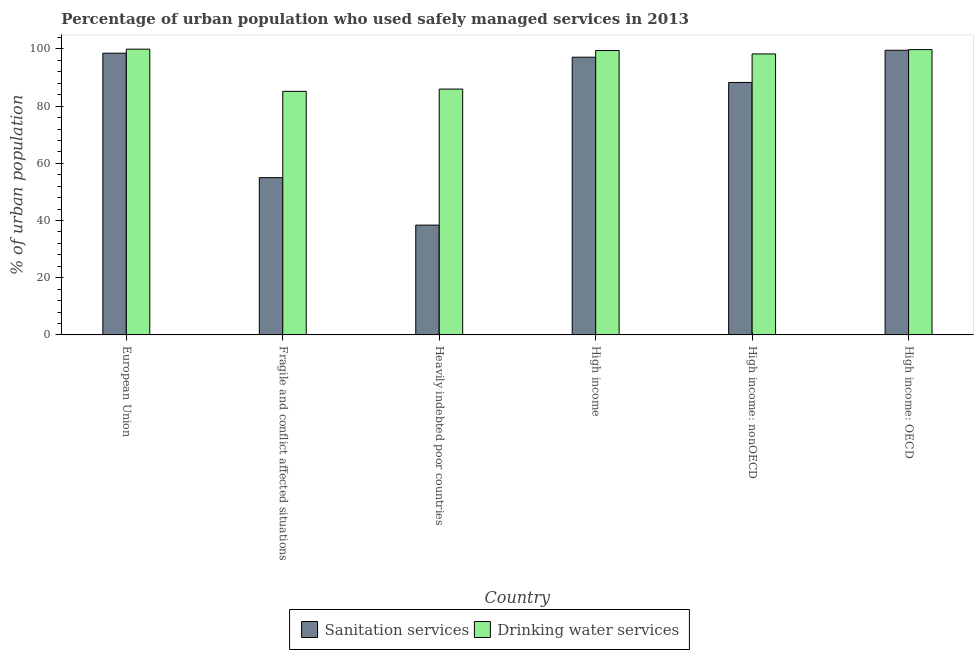How many groups of bars are there?
Your response must be concise. 6. Are the number of bars per tick equal to the number of legend labels?
Your response must be concise. Yes. How many bars are there on the 1st tick from the left?
Give a very brief answer. 2. What is the label of the 5th group of bars from the left?
Your answer should be very brief. High income: nonOECD. In how many cases, is the number of bars for a given country not equal to the number of legend labels?
Provide a short and direct response. 0. What is the percentage of urban population who used sanitation services in High income: nonOECD?
Your answer should be very brief. 88.28. Across all countries, what is the maximum percentage of urban population who used sanitation services?
Your answer should be compact. 99.55. Across all countries, what is the minimum percentage of urban population who used sanitation services?
Your answer should be very brief. 38.4. In which country was the percentage of urban population who used sanitation services maximum?
Keep it short and to the point. High income: OECD. In which country was the percentage of urban population who used drinking water services minimum?
Offer a terse response. Fragile and conflict affected situations. What is the total percentage of urban population who used drinking water services in the graph?
Give a very brief answer. 568.56. What is the difference between the percentage of urban population who used drinking water services in European Union and that in High income?
Your answer should be very brief. 0.48. What is the difference between the percentage of urban population who used sanitation services in European Union and the percentage of urban population who used drinking water services in Heavily indebted poor countries?
Ensure brevity in your answer.  12.55. What is the average percentage of urban population who used drinking water services per country?
Offer a terse response. 94.76. What is the difference between the percentage of urban population who used drinking water services and percentage of urban population who used sanitation services in Fragile and conflict affected situations?
Provide a short and direct response. 30.18. In how many countries, is the percentage of urban population who used sanitation services greater than 28 %?
Give a very brief answer. 6. What is the ratio of the percentage of urban population who used sanitation services in European Union to that in High income: OECD?
Keep it short and to the point. 0.99. Is the percentage of urban population who used drinking water services in European Union less than that in High income: OECD?
Offer a terse response. No. What is the difference between the highest and the second highest percentage of urban population who used sanitation services?
Your response must be concise. 1.03. What is the difference between the highest and the lowest percentage of urban population who used drinking water services?
Offer a terse response. 14.76. In how many countries, is the percentage of urban population who used sanitation services greater than the average percentage of urban population who used sanitation services taken over all countries?
Provide a succinct answer. 4. What does the 2nd bar from the left in High income: nonOECD represents?
Make the answer very short. Drinking water services. What does the 1st bar from the right in Heavily indebted poor countries represents?
Make the answer very short. Drinking water services. Are all the bars in the graph horizontal?
Your response must be concise. No. How many countries are there in the graph?
Ensure brevity in your answer.  6. What is the difference between two consecutive major ticks on the Y-axis?
Give a very brief answer. 20. Does the graph contain any zero values?
Offer a terse response. No. How many legend labels are there?
Your answer should be compact. 2. What is the title of the graph?
Your response must be concise. Percentage of urban population who used safely managed services in 2013. Does "Urban agglomerations" appear as one of the legend labels in the graph?
Provide a short and direct response. No. What is the label or title of the X-axis?
Your answer should be very brief. Country. What is the label or title of the Y-axis?
Ensure brevity in your answer.  % of urban population. What is the % of urban population of Sanitation services in European Union?
Keep it short and to the point. 98.52. What is the % of urban population in Drinking water services in European Union?
Your answer should be very brief. 99.93. What is the % of urban population in Sanitation services in Fragile and conflict affected situations?
Keep it short and to the point. 55. What is the % of urban population in Drinking water services in Fragile and conflict affected situations?
Provide a short and direct response. 85.17. What is the % of urban population in Sanitation services in Heavily indebted poor countries?
Ensure brevity in your answer.  38.4. What is the % of urban population of Drinking water services in Heavily indebted poor countries?
Your response must be concise. 85.97. What is the % of urban population of Sanitation services in High income?
Provide a succinct answer. 97.11. What is the % of urban population of Drinking water services in High income?
Ensure brevity in your answer.  99.45. What is the % of urban population in Sanitation services in High income: nonOECD?
Give a very brief answer. 88.28. What is the % of urban population of Drinking water services in High income: nonOECD?
Your answer should be very brief. 98.26. What is the % of urban population of Sanitation services in High income: OECD?
Ensure brevity in your answer.  99.55. What is the % of urban population of Drinking water services in High income: OECD?
Make the answer very short. 99.77. Across all countries, what is the maximum % of urban population in Sanitation services?
Your answer should be very brief. 99.55. Across all countries, what is the maximum % of urban population of Drinking water services?
Your response must be concise. 99.93. Across all countries, what is the minimum % of urban population of Sanitation services?
Offer a terse response. 38.4. Across all countries, what is the minimum % of urban population of Drinking water services?
Provide a short and direct response. 85.17. What is the total % of urban population in Sanitation services in the graph?
Offer a terse response. 476.85. What is the total % of urban population in Drinking water services in the graph?
Offer a very short reply. 568.56. What is the difference between the % of urban population of Sanitation services in European Union and that in Fragile and conflict affected situations?
Your answer should be very brief. 43.52. What is the difference between the % of urban population in Drinking water services in European Union and that in Fragile and conflict affected situations?
Your answer should be very brief. 14.76. What is the difference between the % of urban population in Sanitation services in European Union and that in Heavily indebted poor countries?
Your response must be concise. 60.12. What is the difference between the % of urban population of Drinking water services in European Union and that in Heavily indebted poor countries?
Ensure brevity in your answer.  13.96. What is the difference between the % of urban population of Sanitation services in European Union and that in High income?
Give a very brief answer. 1.4. What is the difference between the % of urban population of Drinking water services in European Union and that in High income?
Your response must be concise. 0.48. What is the difference between the % of urban population in Sanitation services in European Union and that in High income: nonOECD?
Make the answer very short. 10.23. What is the difference between the % of urban population of Drinking water services in European Union and that in High income: nonOECD?
Give a very brief answer. 1.66. What is the difference between the % of urban population in Sanitation services in European Union and that in High income: OECD?
Your answer should be very brief. -1.03. What is the difference between the % of urban population in Drinking water services in European Union and that in High income: OECD?
Keep it short and to the point. 0.15. What is the difference between the % of urban population in Sanitation services in Fragile and conflict affected situations and that in Heavily indebted poor countries?
Your answer should be very brief. 16.6. What is the difference between the % of urban population in Drinking water services in Fragile and conflict affected situations and that in Heavily indebted poor countries?
Give a very brief answer. -0.8. What is the difference between the % of urban population in Sanitation services in Fragile and conflict affected situations and that in High income?
Provide a succinct answer. -42.12. What is the difference between the % of urban population in Drinking water services in Fragile and conflict affected situations and that in High income?
Give a very brief answer. -14.28. What is the difference between the % of urban population of Sanitation services in Fragile and conflict affected situations and that in High income: nonOECD?
Provide a succinct answer. -33.29. What is the difference between the % of urban population of Drinking water services in Fragile and conflict affected situations and that in High income: nonOECD?
Your answer should be very brief. -13.09. What is the difference between the % of urban population in Sanitation services in Fragile and conflict affected situations and that in High income: OECD?
Offer a terse response. -44.55. What is the difference between the % of urban population of Drinking water services in Fragile and conflict affected situations and that in High income: OECD?
Provide a succinct answer. -14.6. What is the difference between the % of urban population of Sanitation services in Heavily indebted poor countries and that in High income?
Keep it short and to the point. -58.72. What is the difference between the % of urban population of Drinking water services in Heavily indebted poor countries and that in High income?
Offer a very short reply. -13.48. What is the difference between the % of urban population in Sanitation services in Heavily indebted poor countries and that in High income: nonOECD?
Provide a succinct answer. -49.89. What is the difference between the % of urban population in Drinking water services in Heavily indebted poor countries and that in High income: nonOECD?
Keep it short and to the point. -12.29. What is the difference between the % of urban population of Sanitation services in Heavily indebted poor countries and that in High income: OECD?
Keep it short and to the point. -61.15. What is the difference between the % of urban population in Drinking water services in Heavily indebted poor countries and that in High income: OECD?
Ensure brevity in your answer.  -13.8. What is the difference between the % of urban population in Sanitation services in High income and that in High income: nonOECD?
Provide a short and direct response. 8.83. What is the difference between the % of urban population in Drinking water services in High income and that in High income: nonOECD?
Your answer should be compact. 1.19. What is the difference between the % of urban population of Sanitation services in High income and that in High income: OECD?
Your answer should be very brief. -2.43. What is the difference between the % of urban population of Drinking water services in High income and that in High income: OECD?
Your response must be concise. -0.32. What is the difference between the % of urban population in Sanitation services in High income: nonOECD and that in High income: OECD?
Your answer should be compact. -11.26. What is the difference between the % of urban population of Drinking water services in High income: nonOECD and that in High income: OECD?
Your answer should be very brief. -1.51. What is the difference between the % of urban population in Sanitation services in European Union and the % of urban population in Drinking water services in Fragile and conflict affected situations?
Your answer should be very brief. 13.35. What is the difference between the % of urban population of Sanitation services in European Union and the % of urban population of Drinking water services in Heavily indebted poor countries?
Offer a terse response. 12.55. What is the difference between the % of urban population in Sanitation services in European Union and the % of urban population in Drinking water services in High income?
Offer a very short reply. -0.94. What is the difference between the % of urban population in Sanitation services in European Union and the % of urban population in Drinking water services in High income: nonOECD?
Your response must be concise. 0.25. What is the difference between the % of urban population in Sanitation services in European Union and the % of urban population in Drinking water services in High income: OECD?
Your response must be concise. -1.26. What is the difference between the % of urban population in Sanitation services in Fragile and conflict affected situations and the % of urban population in Drinking water services in Heavily indebted poor countries?
Make the answer very short. -30.98. What is the difference between the % of urban population in Sanitation services in Fragile and conflict affected situations and the % of urban population in Drinking water services in High income?
Ensure brevity in your answer.  -44.46. What is the difference between the % of urban population of Sanitation services in Fragile and conflict affected situations and the % of urban population of Drinking water services in High income: nonOECD?
Offer a terse response. -43.27. What is the difference between the % of urban population of Sanitation services in Fragile and conflict affected situations and the % of urban population of Drinking water services in High income: OECD?
Give a very brief answer. -44.78. What is the difference between the % of urban population of Sanitation services in Heavily indebted poor countries and the % of urban population of Drinking water services in High income?
Your response must be concise. -61.06. What is the difference between the % of urban population in Sanitation services in Heavily indebted poor countries and the % of urban population in Drinking water services in High income: nonOECD?
Give a very brief answer. -59.87. What is the difference between the % of urban population in Sanitation services in Heavily indebted poor countries and the % of urban population in Drinking water services in High income: OECD?
Provide a short and direct response. -61.38. What is the difference between the % of urban population of Sanitation services in High income and the % of urban population of Drinking water services in High income: nonOECD?
Your answer should be compact. -1.15. What is the difference between the % of urban population in Sanitation services in High income and the % of urban population in Drinking water services in High income: OECD?
Your answer should be very brief. -2.66. What is the difference between the % of urban population in Sanitation services in High income: nonOECD and the % of urban population in Drinking water services in High income: OECD?
Your response must be concise. -11.49. What is the average % of urban population in Sanitation services per country?
Offer a terse response. 79.48. What is the average % of urban population of Drinking water services per country?
Ensure brevity in your answer.  94.76. What is the difference between the % of urban population of Sanitation services and % of urban population of Drinking water services in European Union?
Keep it short and to the point. -1.41. What is the difference between the % of urban population in Sanitation services and % of urban population in Drinking water services in Fragile and conflict affected situations?
Offer a terse response. -30.18. What is the difference between the % of urban population in Sanitation services and % of urban population in Drinking water services in Heavily indebted poor countries?
Offer a very short reply. -47.57. What is the difference between the % of urban population in Sanitation services and % of urban population in Drinking water services in High income?
Give a very brief answer. -2.34. What is the difference between the % of urban population of Sanitation services and % of urban population of Drinking water services in High income: nonOECD?
Offer a very short reply. -9.98. What is the difference between the % of urban population in Sanitation services and % of urban population in Drinking water services in High income: OECD?
Provide a short and direct response. -0.23. What is the ratio of the % of urban population in Sanitation services in European Union to that in Fragile and conflict affected situations?
Offer a very short reply. 1.79. What is the ratio of the % of urban population in Drinking water services in European Union to that in Fragile and conflict affected situations?
Offer a very short reply. 1.17. What is the ratio of the % of urban population of Sanitation services in European Union to that in Heavily indebted poor countries?
Your answer should be compact. 2.57. What is the ratio of the % of urban population in Drinking water services in European Union to that in Heavily indebted poor countries?
Make the answer very short. 1.16. What is the ratio of the % of urban population in Sanitation services in European Union to that in High income?
Your response must be concise. 1.01. What is the ratio of the % of urban population of Drinking water services in European Union to that in High income?
Your answer should be very brief. 1. What is the ratio of the % of urban population in Sanitation services in European Union to that in High income: nonOECD?
Ensure brevity in your answer.  1.12. What is the ratio of the % of urban population in Drinking water services in European Union to that in High income: nonOECD?
Provide a short and direct response. 1.02. What is the ratio of the % of urban population in Drinking water services in European Union to that in High income: OECD?
Provide a succinct answer. 1. What is the ratio of the % of urban population in Sanitation services in Fragile and conflict affected situations to that in Heavily indebted poor countries?
Keep it short and to the point. 1.43. What is the ratio of the % of urban population of Drinking water services in Fragile and conflict affected situations to that in Heavily indebted poor countries?
Your answer should be very brief. 0.99. What is the ratio of the % of urban population of Sanitation services in Fragile and conflict affected situations to that in High income?
Offer a terse response. 0.57. What is the ratio of the % of urban population in Drinking water services in Fragile and conflict affected situations to that in High income?
Your answer should be very brief. 0.86. What is the ratio of the % of urban population of Sanitation services in Fragile and conflict affected situations to that in High income: nonOECD?
Give a very brief answer. 0.62. What is the ratio of the % of urban population of Drinking water services in Fragile and conflict affected situations to that in High income: nonOECD?
Give a very brief answer. 0.87. What is the ratio of the % of urban population of Sanitation services in Fragile and conflict affected situations to that in High income: OECD?
Provide a short and direct response. 0.55. What is the ratio of the % of urban population of Drinking water services in Fragile and conflict affected situations to that in High income: OECD?
Your answer should be compact. 0.85. What is the ratio of the % of urban population of Sanitation services in Heavily indebted poor countries to that in High income?
Offer a terse response. 0.4. What is the ratio of the % of urban population of Drinking water services in Heavily indebted poor countries to that in High income?
Offer a very short reply. 0.86. What is the ratio of the % of urban population in Sanitation services in Heavily indebted poor countries to that in High income: nonOECD?
Offer a terse response. 0.43. What is the ratio of the % of urban population in Drinking water services in Heavily indebted poor countries to that in High income: nonOECD?
Provide a succinct answer. 0.87. What is the ratio of the % of urban population of Sanitation services in Heavily indebted poor countries to that in High income: OECD?
Ensure brevity in your answer.  0.39. What is the ratio of the % of urban population of Drinking water services in Heavily indebted poor countries to that in High income: OECD?
Give a very brief answer. 0.86. What is the ratio of the % of urban population of Drinking water services in High income to that in High income: nonOECD?
Offer a very short reply. 1.01. What is the ratio of the % of urban population in Sanitation services in High income to that in High income: OECD?
Ensure brevity in your answer.  0.98. What is the ratio of the % of urban population in Drinking water services in High income to that in High income: OECD?
Ensure brevity in your answer.  1. What is the ratio of the % of urban population of Sanitation services in High income: nonOECD to that in High income: OECD?
Your answer should be compact. 0.89. What is the ratio of the % of urban population in Drinking water services in High income: nonOECD to that in High income: OECD?
Your answer should be compact. 0.98. What is the difference between the highest and the second highest % of urban population of Sanitation services?
Provide a succinct answer. 1.03. What is the difference between the highest and the second highest % of urban population in Drinking water services?
Provide a succinct answer. 0.15. What is the difference between the highest and the lowest % of urban population of Sanitation services?
Provide a short and direct response. 61.15. What is the difference between the highest and the lowest % of urban population in Drinking water services?
Your answer should be compact. 14.76. 